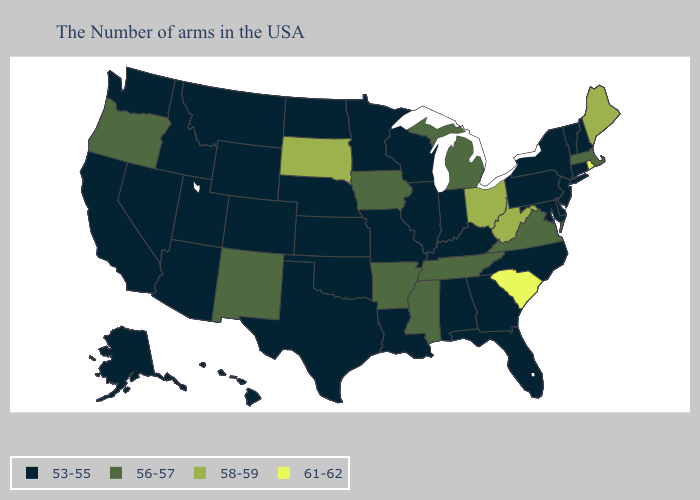What is the value of Michigan?
Be succinct. 56-57. Does Iowa have the lowest value in the USA?
Write a very short answer. No. What is the highest value in the West ?
Concise answer only. 56-57. Among the states that border California , which have the lowest value?
Short answer required. Arizona, Nevada. How many symbols are there in the legend?
Give a very brief answer. 4. Which states have the lowest value in the USA?
Quick response, please. New Hampshire, Vermont, Connecticut, New York, New Jersey, Delaware, Maryland, Pennsylvania, North Carolina, Florida, Georgia, Kentucky, Indiana, Alabama, Wisconsin, Illinois, Louisiana, Missouri, Minnesota, Kansas, Nebraska, Oklahoma, Texas, North Dakota, Wyoming, Colorado, Utah, Montana, Arizona, Idaho, Nevada, California, Washington, Alaska, Hawaii. What is the lowest value in the South?
Short answer required. 53-55. What is the value of Utah?
Quick response, please. 53-55. How many symbols are there in the legend?
Keep it brief. 4. What is the lowest value in the USA?
Keep it brief. 53-55. Among the states that border Arizona , does New Mexico have the lowest value?
Answer briefly. No. What is the value of Virginia?
Concise answer only. 56-57. What is the value of Tennessee?
Give a very brief answer. 56-57. Name the states that have a value in the range 53-55?
Keep it brief. New Hampshire, Vermont, Connecticut, New York, New Jersey, Delaware, Maryland, Pennsylvania, North Carolina, Florida, Georgia, Kentucky, Indiana, Alabama, Wisconsin, Illinois, Louisiana, Missouri, Minnesota, Kansas, Nebraska, Oklahoma, Texas, North Dakota, Wyoming, Colorado, Utah, Montana, Arizona, Idaho, Nevada, California, Washington, Alaska, Hawaii. Name the states that have a value in the range 56-57?
Be succinct. Massachusetts, Virginia, Michigan, Tennessee, Mississippi, Arkansas, Iowa, New Mexico, Oregon. 